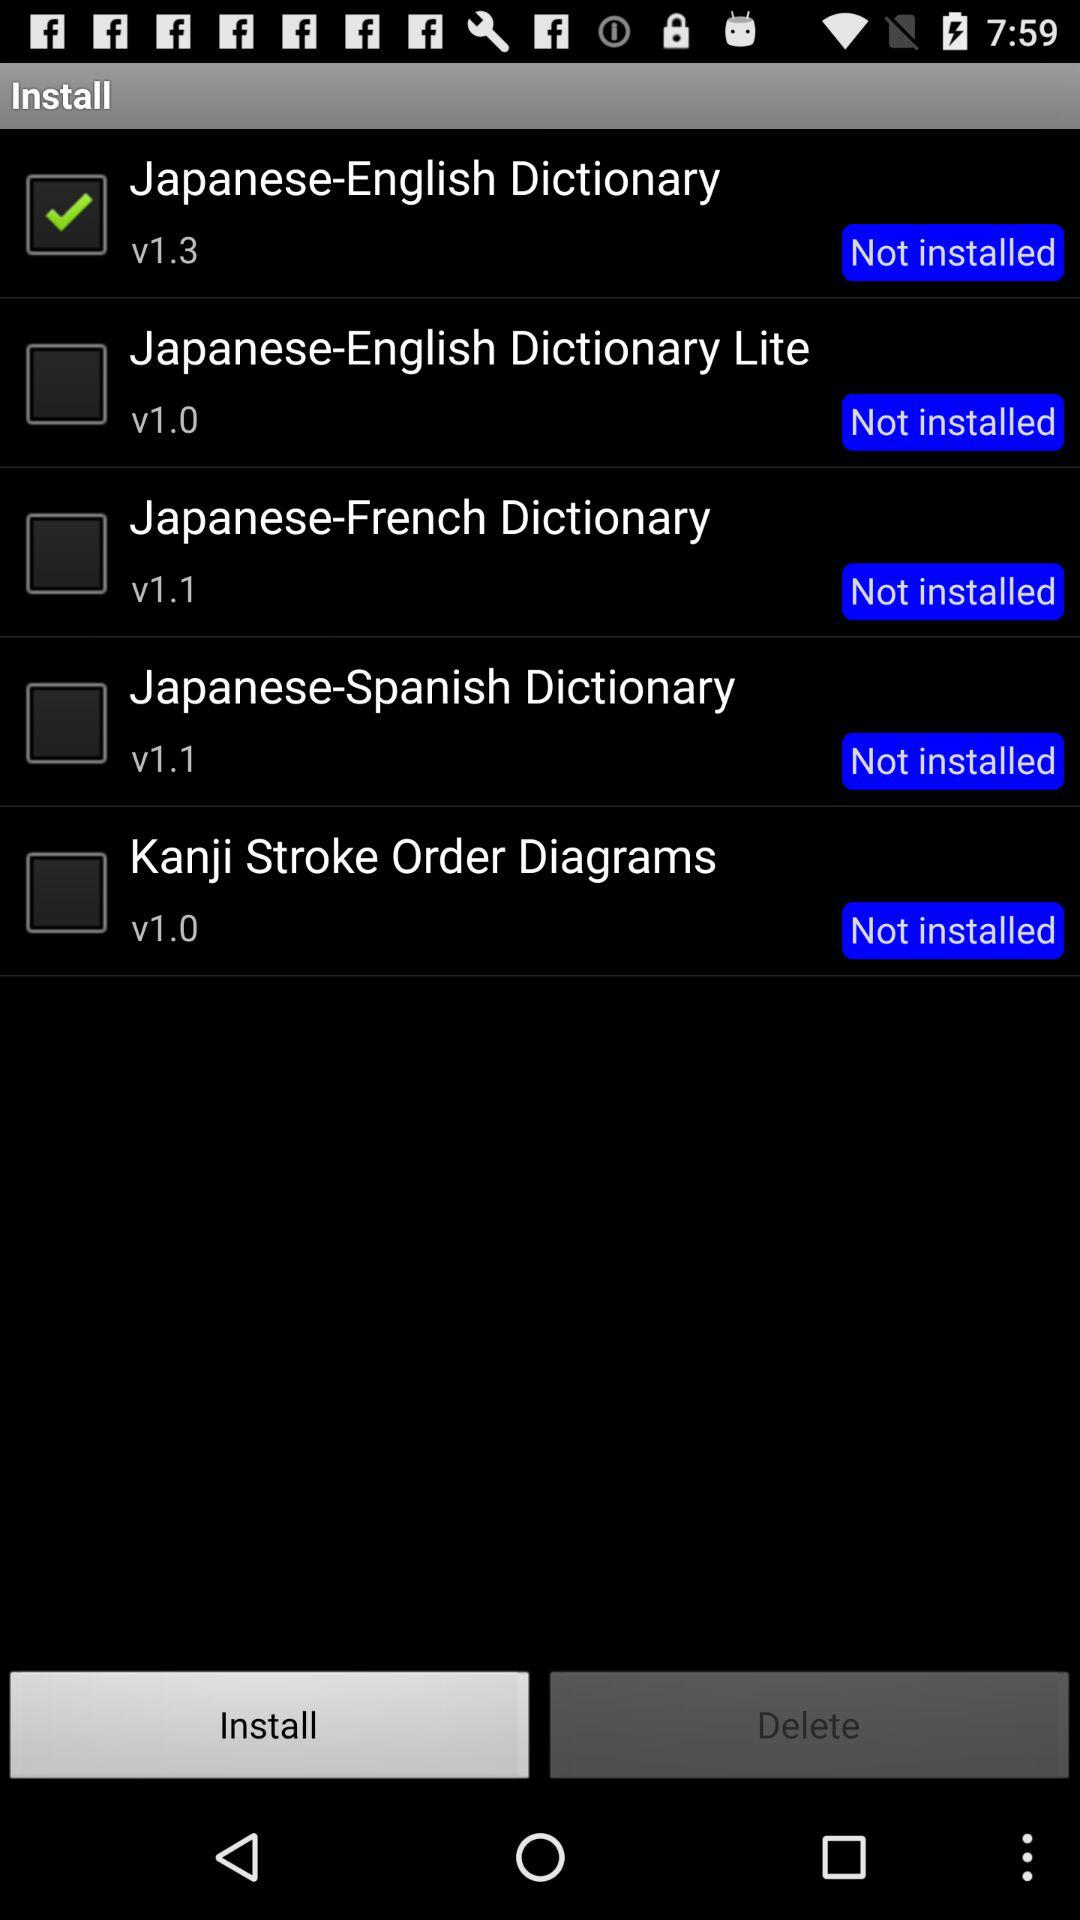What is the application version of the "Japanese-English Dictionary"? The version of the application "Japanese-English Dictionary" is v1.3. 